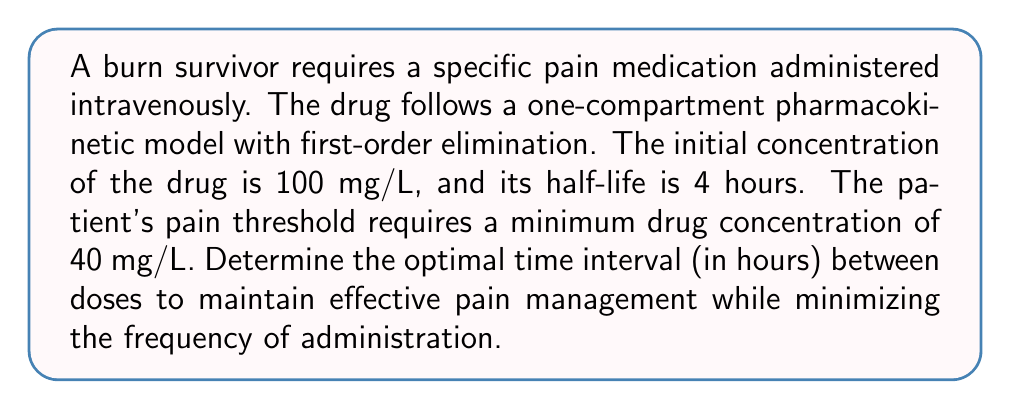Show me your answer to this math problem. To solve this problem, we need to use the first-order elimination model and determine when the drug concentration reaches the minimum required level. Let's approach this step-by-step:

1. The first-order elimination model is given by the equation:
   $$ C(t) = C_0 e^{-kt} $$
   where $C(t)$ is the concentration at time $t$, $C_0$ is the initial concentration, and $k$ is the elimination rate constant.

2. We need to find $k$ using the half-life ($t_{1/2}$):
   $$ k = \frac{\ln(2)}{t_{1/2}} = \frac{\ln(2)}{4} = 0.1733 \text{ h}^{-1} $$

3. Now, we want to find the time $t$ when the concentration reaches 40 mg/L:
   $$ 40 = 100 e^{-0.1733t} $$

4. Solving for $t$:
   $$ \ln(0.4) = -0.1733t $$
   $$ t = \frac{-\ln(0.4)}{0.1733} = 5.31 \text{ hours} $$

5. To optimize the dosing interval, we round down to the nearest hour to ensure the concentration doesn't fall below the pain threshold:
   Optimal dosing interval = 5 hours

This interval balances effective pain management with minimized administration frequency for the burn survivor's post-operative care.
Answer: 5 hours 